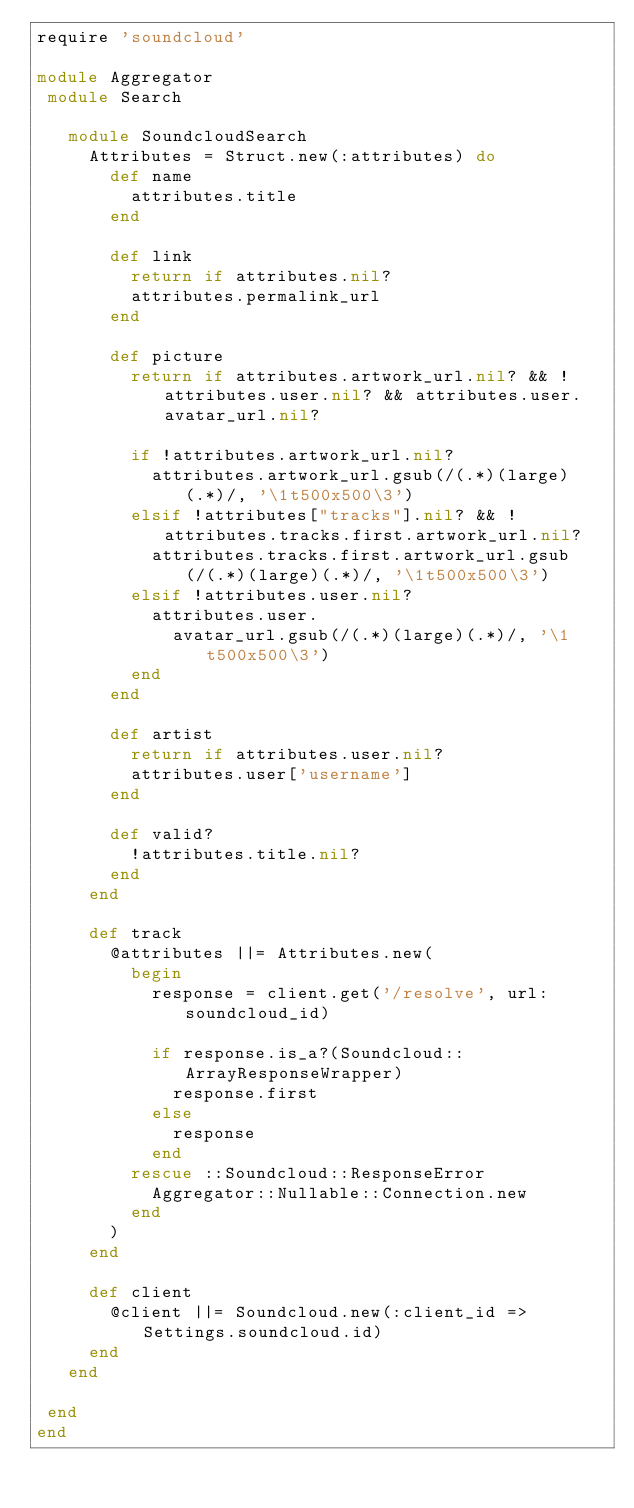Convert code to text. <code><loc_0><loc_0><loc_500><loc_500><_Ruby_>require 'soundcloud'

module Aggregator
 module Search

   module SoundcloudSearch
     Attributes = Struct.new(:attributes) do
       def name
         attributes.title
       end

       def link
         return if attributes.nil?
         attributes.permalink_url
       end

       def picture
         return if attributes.artwork_url.nil? && !attributes.user.nil? && attributes.user.avatar_url.nil?

         if !attributes.artwork_url.nil?
           attributes.artwork_url.gsub(/(.*)(large)(.*)/, '\1t500x500\3')
         elsif !attributes["tracks"].nil? && !attributes.tracks.first.artwork_url.nil?
           attributes.tracks.first.artwork_url.gsub(/(.*)(large)(.*)/, '\1t500x500\3')
         elsif !attributes.user.nil?
           attributes.user.
             avatar_url.gsub(/(.*)(large)(.*)/, '\1t500x500\3')
         end
       end

       def artist
         return if attributes.user.nil?
         attributes.user['username']
       end

       def valid?
         !attributes.title.nil?
       end
     end

     def track
       @attributes ||= Attributes.new(
         begin
           response = client.get('/resolve', url: soundcloud_id)

           if response.is_a?(Soundcloud::ArrayResponseWrapper)
             response.first
           else
             response
           end
         rescue ::Soundcloud::ResponseError
           Aggregator::Nullable::Connection.new
         end
       )
     end

     def client
       @client ||= Soundcloud.new(:client_id => Settings.soundcloud.id)
     end
   end

 end
end
</code> 